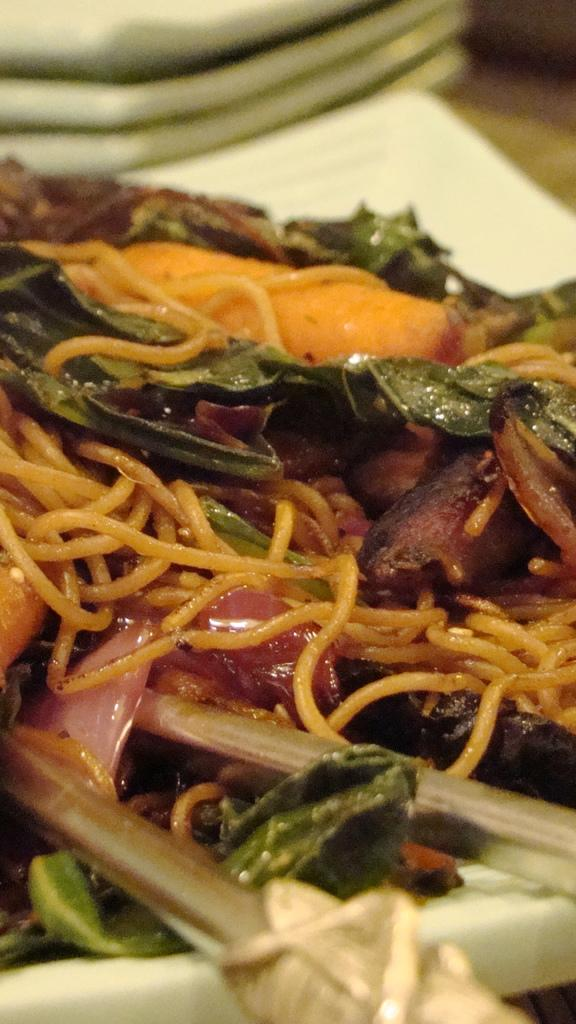What is the food item in the plate in the image? Unfortunately, the specific food item cannot be identified from the provided facts. What utensils are present in the image? There are chopsticks in the image. Can you describe the object in the background of the image? The object in the background is blurry, so it cannot be accurately described. What type of chalk is being used to draw on the top of the plate in the image? There is no chalk or drawing present in the image; it features a plate with a food item and chopsticks. 